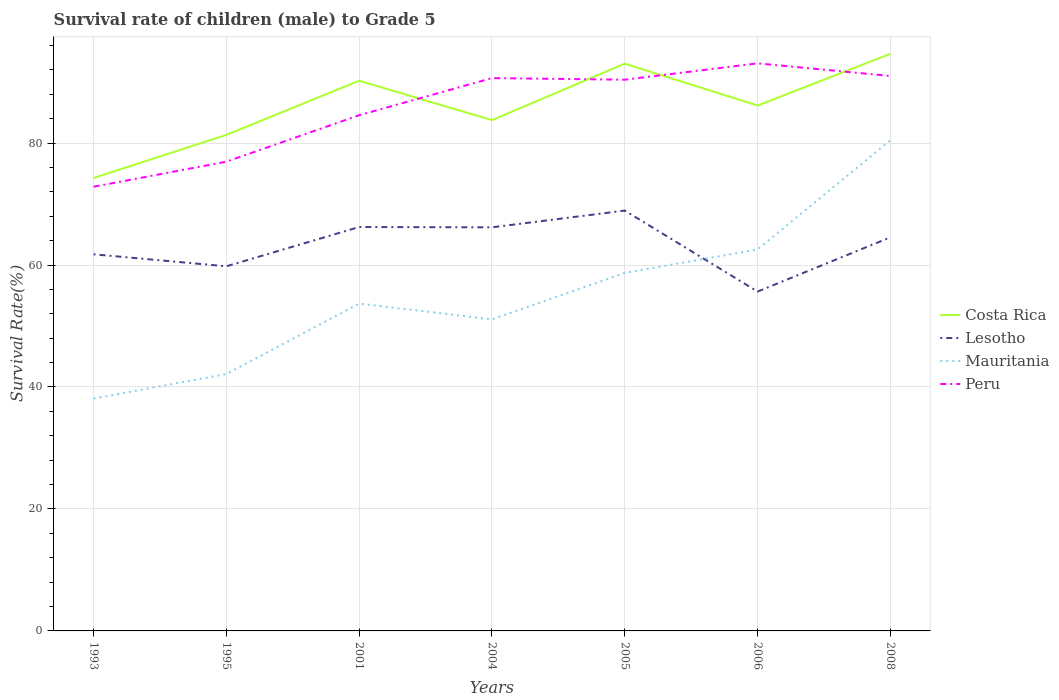Across all years, what is the maximum survival rate of male children to grade 5 in Lesotho?
Ensure brevity in your answer.  55.65. What is the total survival rate of male children to grade 5 in Mauritania in the graph?
Your answer should be compact. -15.57. What is the difference between the highest and the second highest survival rate of male children to grade 5 in Mauritania?
Offer a terse response. 42.36. How many lines are there?
Ensure brevity in your answer.  4. Does the graph contain grids?
Give a very brief answer. Yes. Where does the legend appear in the graph?
Ensure brevity in your answer.  Center right. What is the title of the graph?
Keep it short and to the point. Survival rate of children (male) to Grade 5. What is the label or title of the X-axis?
Your response must be concise. Years. What is the label or title of the Y-axis?
Provide a succinct answer. Survival Rate(%). What is the Survival Rate(%) of Costa Rica in 1993?
Ensure brevity in your answer.  74.27. What is the Survival Rate(%) of Lesotho in 1993?
Provide a succinct answer. 61.76. What is the Survival Rate(%) in Mauritania in 1993?
Give a very brief answer. 38.1. What is the Survival Rate(%) of Peru in 1993?
Your response must be concise. 72.83. What is the Survival Rate(%) of Costa Rica in 1995?
Ensure brevity in your answer.  81.34. What is the Survival Rate(%) of Lesotho in 1995?
Ensure brevity in your answer.  59.79. What is the Survival Rate(%) in Mauritania in 1995?
Provide a succinct answer. 42.12. What is the Survival Rate(%) in Peru in 1995?
Give a very brief answer. 76.94. What is the Survival Rate(%) of Costa Rica in 2001?
Provide a succinct answer. 90.22. What is the Survival Rate(%) of Lesotho in 2001?
Your answer should be very brief. 66.23. What is the Survival Rate(%) in Mauritania in 2001?
Give a very brief answer. 53.68. What is the Survival Rate(%) in Peru in 2001?
Offer a terse response. 84.56. What is the Survival Rate(%) in Costa Rica in 2004?
Your answer should be compact. 83.76. What is the Survival Rate(%) of Lesotho in 2004?
Offer a terse response. 66.18. What is the Survival Rate(%) of Mauritania in 2004?
Offer a terse response. 51.09. What is the Survival Rate(%) of Peru in 2004?
Your response must be concise. 90.65. What is the Survival Rate(%) of Costa Rica in 2005?
Provide a succinct answer. 93.02. What is the Survival Rate(%) in Lesotho in 2005?
Provide a succinct answer. 68.93. What is the Survival Rate(%) of Mauritania in 2005?
Your response must be concise. 58.7. What is the Survival Rate(%) in Peru in 2005?
Your answer should be compact. 90.39. What is the Survival Rate(%) in Costa Rica in 2006?
Ensure brevity in your answer.  86.16. What is the Survival Rate(%) in Lesotho in 2006?
Provide a succinct answer. 55.65. What is the Survival Rate(%) of Mauritania in 2006?
Keep it short and to the point. 62.55. What is the Survival Rate(%) in Peru in 2006?
Offer a terse response. 93.07. What is the Survival Rate(%) in Costa Rica in 2008?
Offer a terse response. 94.63. What is the Survival Rate(%) of Lesotho in 2008?
Provide a short and direct response. 64.55. What is the Survival Rate(%) in Mauritania in 2008?
Make the answer very short. 80.47. What is the Survival Rate(%) in Peru in 2008?
Your answer should be very brief. 91. Across all years, what is the maximum Survival Rate(%) in Costa Rica?
Offer a terse response. 94.63. Across all years, what is the maximum Survival Rate(%) of Lesotho?
Provide a short and direct response. 68.93. Across all years, what is the maximum Survival Rate(%) of Mauritania?
Your response must be concise. 80.47. Across all years, what is the maximum Survival Rate(%) in Peru?
Give a very brief answer. 93.07. Across all years, what is the minimum Survival Rate(%) of Costa Rica?
Your answer should be very brief. 74.27. Across all years, what is the minimum Survival Rate(%) of Lesotho?
Make the answer very short. 55.65. Across all years, what is the minimum Survival Rate(%) in Mauritania?
Keep it short and to the point. 38.1. Across all years, what is the minimum Survival Rate(%) of Peru?
Offer a terse response. 72.83. What is the total Survival Rate(%) in Costa Rica in the graph?
Your answer should be compact. 603.4. What is the total Survival Rate(%) in Lesotho in the graph?
Keep it short and to the point. 443.08. What is the total Survival Rate(%) of Mauritania in the graph?
Your answer should be very brief. 386.71. What is the total Survival Rate(%) of Peru in the graph?
Keep it short and to the point. 599.45. What is the difference between the Survival Rate(%) in Costa Rica in 1993 and that in 1995?
Give a very brief answer. -7.07. What is the difference between the Survival Rate(%) in Lesotho in 1993 and that in 1995?
Give a very brief answer. 1.97. What is the difference between the Survival Rate(%) of Mauritania in 1993 and that in 1995?
Offer a terse response. -4.02. What is the difference between the Survival Rate(%) in Peru in 1993 and that in 1995?
Provide a succinct answer. -4.11. What is the difference between the Survival Rate(%) of Costa Rica in 1993 and that in 2001?
Offer a very short reply. -15.95. What is the difference between the Survival Rate(%) of Lesotho in 1993 and that in 2001?
Your answer should be compact. -4.47. What is the difference between the Survival Rate(%) in Mauritania in 1993 and that in 2001?
Make the answer very short. -15.57. What is the difference between the Survival Rate(%) of Peru in 1993 and that in 2001?
Your answer should be compact. -11.73. What is the difference between the Survival Rate(%) in Costa Rica in 1993 and that in 2004?
Offer a very short reply. -9.49. What is the difference between the Survival Rate(%) of Lesotho in 1993 and that in 2004?
Keep it short and to the point. -4.42. What is the difference between the Survival Rate(%) in Mauritania in 1993 and that in 2004?
Your answer should be compact. -12.99. What is the difference between the Survival Rate(%) of Peru in 1993 and that in 2004?
Offer a very short reply. -17.82. What is the difference between the Survival Rate(%) of Costa Rica in 1993 and that in 2005?
Keep it short and to the point. -18.75. What is the difference between the Survival Rate(%) in Lesotho in 1993 and that in 2005?
Provide a succinct answer. -7.17. What is the difference between the Survival Rate(%) of Mauritania in 1993 and that in 2005?
Give a very brief answer. -20.6. What is the difference between the Survival Rate(%) of Peru in 1993 and that in 2005?
Your answer should be compact. -17.55. What is the difference between the Survival Rate(%) in Costa Rica in 1993 and that in 2006?
Provide a short and direct response. -11.89. What is the difference between the Survival Rate(%) of Lesotho in 1993 and that in 2006?
Your answer should be compact. 6.12. What is the difference between the Survival Rate(%) of Mauritania in 1993 and that in 2006?
Offer a very short reply. -24.45. What is the difference between the Survival Rate(%) in Peru in 1993 and that in 2006?
Ensure brevity in your answer.  -20.24. What is the difference between the Survival Rate(%) of Costa Rica in 1993 and that in 2008?
Ensure brevity in your answer.  -20.37. What is the difference between the Survival Rate(%) of Lesotho in 1993 and that in 2008?
Give a very brief answer. -2.79. What is the difference between the Survival Rate(%) in Mauritania in 1993 and that in 2008?
Make the answer very short. -42.36. What is the difference between the Survival Rate(%) in Peru in 1993 and that in 2008?
Your answer should be compact. -18.16. What is the difference between the Survival Rate(%) of Costa Rica in 1995 and that in 2001?
Provide a succinct answer. -8.88. What is the difference between the Survival Rate(%) of Lesotho in 1995 and that in 2001?
Offer a terse response. -6.44. What is the difference between the Survival Rate(%) of Mauritania in 1995 and that in 2001?
Your answer should be very brief. -11.55. What is the difference between the Survival Rate(%) of Peru in 1995 and that in 2001?
Provide a short and direct response. -7.62. What is the difference between the Survival Rate(%) in Costa Rica in 1995 and that in 2004?
Provide a succinct answer. -2.42. What is the difference between the Survival Rate(%) in Lesotho in 1995 and that in 2004?
Your answer should be very brief. -6.39. What is the difference between the Survival Rate(%) in Mauritania in 1995 and that in 2004?
Make the answer very short. -8.97. What is the difference between the Survival Rate(%) in Peru in 1995 and that in 2004?
Your answer should be compact. -13.71. What is the difference between the Survival Rate(%) in Costa Rica in 1995 and that in 2005?
Offer a terse response. -11.68. What is the difference between the Survival Rate(%) of Lesotho in 1995 and that in 2005?
Your response must be concise. -9.14. What is the difference between the Survival Rate(%) in Mauritania in 1995 and that in 2005?
Give a very brief answer. -16.58. What is the difference between the Survival Rate(%) in Peru in 1995 and that in 2005?
Provide a succinct answer. -13.44. What is the difference between the Survival Rate(%) in Costa Rica in 1995 and that in 2006?
Your response must be concise. -4.82. What is the difference between the Survival Rate(%) of Lesotho in 1995 and that in 2006?
Ensure brevity in your answer.  4.14. What is the difference between the Survival Rate(%) in Mauritania in 1995 and that in 2006?
Make the answer very short. -20.43. What is the difference between the Survival Rate(%) in Peru in 1995 and that in 2006?
Keep it short and to the point. -16.13. What is the difference between the Survival Rate(%) of Costa Rica in 1995 and that in 2008?
Your answer should be very brief. -13.29. What is the difference between the Survival Rate(%) in Lesotho in 1995 and that in 2008?
Provide a short and direct response. -4.76. What is the difference between the Survival Rate(%) of Mauritania in 1995 and that in 2008?
Your answer should be compact. -38.34. What is the difference between the Survival Rate(%) in Peru in 1995 and that in 2008?
Your answer should be very brief. -14.05. What is the difference between the Survival Rate(%) in Costa Rica in 2001 and that in 2004?
Provide a succinct answer. 6.46. What is the difference between the Survival Rate(%) in Lesotho in 2001 and that in 2004?
Give a very brief answer. 0.05. What is the difference between the Survival Rate(%) of Mauritania in 2001 and that in 2004?
Provide a short and direct response. 2.58. What is the difference between the Survival Rate(%) of Peru in 2001 and that in 2004?
Provide a short and direct response. -6.09. What is the difference between the Survival Rate(%) in Costa Rica in 2001 and that in 2005?
Your answer should be very brief. -2.8. What is the difference between the Survival Rate(%) of Lesotho in 2001 and that in 2005?
Your answer should be very brief. -2.69. What is the difference between the Survival Rate(%) in Mauritania in 2001 and that in 2005?
Your response must be concise. -5.03. What is the difference between the Survival Rate(%) in Peru in 2001 and that in 2005?
Ensure brevity in your answer.  -5.83. What is the difference between the Survival Rate(%) of Costa Rica in 2001 and that in 2006?
Your answer should be very brief. 4.06. What is the difference between the Survival Rate(%) in Lesotho in 2001 and that in 2006?
Your answer should be compact. 10.59. What is the difference between the Survival Rate(%) of Mauritania in 2001 and that in 2006?
Provide a short and direct response. -8.88. What is the difference between the Survival Rate(%) of Peru in 2001 and that in 2006?
Ensure brevity in your answer.  -8.51. What is the difference between the Survival Rate(%) of Costa Rica in 2001 and that in 2008?
Your response must be concise. -4.42. What is the difference between the Survival Rate(%) of Lesotho in 2001 and that in 2008?
Your response must be concise. 1.69. What is the difference between the Survival Rate(%) in Mauritania in 2001 and that in 2008?
Your response must be concise. -26.79. What is the difference between the Survival Rate(%) of Peru in 2001 and that in 2008?
Your response must be concise. -6.43. What is the difference between the Survival Rate(%) in Costa Rica in 2004 and that in 2005?
Keep it short and to the point. -9.26. What is the difference between the Survival Rate(%) in Lesotho in 2004 and that in 2005?
Your answer should be compact. -2.75. What is the difference between the Survival Rate(%) in Mauritania in 2004 and that in 2005?
Your answer should be compact. -7.61. What is the difference between the Survival Rate(%) in Peru in 2004 and that in 2005?
Provide a succinct answer. 0.26. What is the difference between the Survival Rate(%) in Costa Rica in 2004 and that in 2006?
Make the answer very short. -2.39. What is the difference between the Survival Rate(%) in Lesotho in 2004 and that in 2006?
Your answer should be very brief. 10.54. What is the difference between the Survival Rate(%) of Mauritania in 2004 and that in 2006?
Provide a succinct answer. -11.46. What is the difference between the Survival Rate(%) of Peru in 2004 and that in 2006?
Give a very brief answer. -2.42. What is the difference between the Survival Rate(%) in Costa Rica in 2004 and that in 2008?
Offer a very short reply. -10.87. What is the difference between the Survival Rate(%) in Lesotho in 2004 and that in 2008?
Offer a very short reply. 1.63. What is the difference between the Survival Rate(%) in Mauritania in 2004 and that in 2008?
Your response must be concise. -29.37. What is the difference between the Survival Rate(%) of Peru in 2004 and that in 2008?
Provide a short and direct response. -0.34. What is the difference between the Survival Rate(%) of Costa Rica in 2005 and that in 2006?
Give a very brief answer. 6.87. What is the difference between the Survival Rate(%) of Lesotho in 2005 and that in 2006?
Ensure brevity in your answer.  13.28. What is the difference between the Survival Rate(%) in Mauritania in 2005 and that in 2006?
Provide a succinct answer. -3.85. What is the difference between the Survival Rate(%) of Peru in 2005 and that in 2006?
Ensure brevity in your answer.  -2.68. What is the difference between the Survival Rate(%) in Costa Rica in 2005 and that in 2008?
Offer a very short reply. -1.61. What is the difference between the Survival Rate(%) of Lesotho in 2005 and that in 2008?
Offer a terse response. 4.38. What is the difference between the Survival Rate(%) in Mauritania in 2005 and that in 2008?
Provide a short and direct response. -21.76. What is the difference between the Survival Rate(%) of Peru in 2005 and that in 2008?
Provide a short and direct response. -0.61. What is the difference between the Survival Rate(%) in Costa Rica in 2006 and that in 2008?
Your response must be concise. -8.48. What is the difference between the Survival Rate(%) in Lesotho in 2006 and that in 2008?
Give a very brief answer. -8.9. What is the difference between the Survival Rate(%) in Mauritania in 2006 and that in 2008?
Ensure brevity in your answer.  -17.91. What is the difference between the Survival Rate(%) of Peru in 2006 and that in 2008?
Give a very brief answer. 2.07. What is the difference between the Survival Rate(%) of Costa Rica in 1993 and the Survival Rate(%) of Lesotho in 1995?
Your answer should be compact. 14.48. What is the difference between the Survival Rate(%) of Costa Rica in 1993 and the Survival Rate(%) of Mauritania in 1995?
Your answer should be very brief. 32.15. What is the difference between the Survival Rate(%) of Costa Rica in 1993 and the Survival Rate(%) of Peru in 1995?
Your response must be concise. -2.67. What is the difference between the Survival Rate(%) of Lesotho in 1993 and the Survival Rate(%) of Mauritania in 1995?
Provide a succinct answer. 19.64. What is the difference between the Survival Rate(%) of Lesotho in 1993 and the Survival Rate(%) of Peru in 1995?
Ensure brevity in your answer.  -15.18. What is the difference between the Survival Rate(%) in Mauritania in 1993 and the Survival Rate(%) in Peru in 1995?
Give a very brief answer. -38.84. What is the difference between the Survival Rate(%) of Costa Rica in 1993 and the Survival Rate(%) of Lesotho in 2001?
Ensure brevity in your answer.  8.04. What is the difference between the Survival Rate(%) in Costa Rica in 1993 and the Survival Rate(%) in Mauritania in 2001?
Your response must be concise. 20.59. What is the difference between the Survival Rate(%) in Costa Rica in 1993 and the Survival Rate(%) in Peru in 2001?
Offer a very short reply. -10.29. What is the difference between the Survival Rate(%) in Lesotho in 1993 and the Survival Rate(%) in Mauritania in 2001?
Provide a succinct answer. 8.09. What is the difference between the Survival Rate(%) in Lesotho in 1993 and the Survival Rate(%) in Peru in 2001?
Provide a short and direct response. -22.8. What is the difference between the Survival Rate(%) in Mauritania in 1993 and the Survival Rate(%) in Peru in 2001?
Your answer should be compact. -46.46. What is the difference between the Survival Rate(%) of Costa Rica in 1993 and the Survival Rate(%) of Lesotho in 2004?
Your response must be concise. 8.09. What is the difference between the Survival Rate(%) of Costa Rica in 1993 and the Survival Rate(%) of Mauritania in 2004?
Your answer should be very brief. 23.18. What is the difference between the Survival Rate(%) in Costa Rica in 1993 and the Survival Rate(%) in Peru in 2004?
Give a very brief answer. -16.38. What is the difference between the Survival Rate(%) in Lesotho in 1993 and the Survival Rate(%) in Mauritania in 2004?
Your response must be concise. 10.67. What is the difference between the Survival Rate(%) in Lesotho in 1993 and the Survival Rate(%) in Peru in 2004?
Make the answer very short. -28.89. What is the difference between the Survival Rate(%) in Mauritania in 1993 and the Survival Rate(%) in Peru in 2004?
Offer a terse response. -52.55. What is the difference between the Survival Rate(%) of Costa Rica in 1993 and the Survival Rate(%) of Lesotho in 2005?
Provide a succinct answer. 5.34. What is the difference between the Survival Rate(%) in Costa Rica in 1993 and the Survival Rate(%) in Mauritania in 2005?
Your answer should be very brief. 15.57. What is the difference between the Survival Rate(%) of Costa Rica in 1993 and the Survival Rate(%) of Peru in 2005?
Your response must be concise. -16.12. What is the difference between the Survival Rate(%) of Lesotho in 1993 and the Survival Rate(%) of Mauritania in 2005?
Make the answer very short. 3.06. What is the difference between the Survival Rate(%) of Lesotho in 1993 and the Survival Rate(%) of Peru in 2005?
Offer a very short reply. -28.63. What is the difference between the Survival Rate(%) in Mauritania in 1993 and the Survival Rate(%) in Peru in 2005?
Provide a succinct answer. -52.29. What is the difference between the Survival Rate(%) in Costa Rica in 1993 and the Survival Rate(%) in Lesotho in 2006?
Your response must be concise. 18.62. What is the difference between the Survival Rate(%) in Costa Rica in 1993 and the Survival Rate(%) in Mauritania in 2006?
Provide a succinct answer. 11.72. What is the difference between the Survival Rate(%) in Costa Rica in 1993 and the Survival Rate(%) in Peru in 2006?
Offer a very short reply. -18.8. What is the difference between the Survival Rate(%) of Lesotho in 1993 and the Survival Rate(%) of Mauritania in 2006?
Provide a succinct answer. -0.79. What is the difference between the Survival Rate(%) in Lesotho in 1993 and the Survival Rate(%) in Peru in 2006?
Make the answer very short. -31.31. What is the difference between the Survival Rate(%) of Mauritania in 1993 and the Survival Rate(%) of Peru in 2006?
Make the answer very short. -54.97. What is the difference between the Survival Rate(%) of Costa Rica in 1993 and the Survival Rate(%) of Lesotho in 2008?
Make the answer very short. 9.72. What is the difference between the Survival Rate(%) in Costa Rica in 1993 and the Survival Rate(%) in Mauritania in 2008?
Offer a terse response. -6.2. What is the difference between the Survival Rate(%) in Costa Rica in 1993 and the Survival Rate(%) in Peru in 2008?
Your answer should be very brief. -16.73. What is the difference between the Survival Rate(%) in Lesotho in 1993 and the Survival Rate(%) in Mauritania in 2008?
Make the answer very short. -18.71. What is the difference between the Survival Rate(%) of Lesotho in 1993 and the Survival Rate(%) of Peru in 2008?
Provide a short and direct response. -29.24. What is the difference between the Survival Rate(%) of Mauritania in 1993 and the Survival Rate(%) of Peru in 2008?
Provide a short and direct response. -52.9. What is the difference between the Survival Rate(%) in Costa Rica in 1995 and the Survival Rate(%) in Lesotho in 2001?
Keep it short and to the point. 15.11. What is the difference between the Survival Rate(%) of Costa Rica in 1995 and the Survival Rate(%) of Mauritania in 2001?
Keep it short and to the point. 27.67. What is the difference between the Survival Rate(%) in Costa Rica in 1995 and the Survival Rate(%) in Peru in 2001?
Offer a very short reply. -3.22. What is the difference between the Survival Rate(%) in Lesotho in 1995 and the Survival Rate(%) in Mauritania in 2001?
Your answer should be compact. 6.11. What is the difference between the Survival Rate(%) of Lesotho in 1995 and the Survival Rate(%) of Peru in 2001?
Provide a short and direct response. -24.77. What is the difference between the Survival Rate(%) in Mauritania in 1995 and the Survival Rate(%) in Peru in 2001?
Provide a succinct answer. -42.44. What is the difference between the Survival Rate(%) in Costa Rica in 1995 and the Survival Rate(%) in Lesotho in 2004?
Keep it short and to the point. 15.16. What is the difference between the Survival Rate(%) of Costa Rica in 1995 and the Survival Rate(%) of Mauritania in 2004?
Give a very brief answer. 30.25. What is the difference between the Survival Rate(%) in Costa Rica in 1995 and the Survival Rate(%) in Peru in 2004?
Provide a succinct answer. -9.31. What is the difference between the Survival Rate(%) in Lesotho in 1995 and the Survival Rate(%) in Mauritania in 2004?
Keep it short and to the point. 8.7. What is the difference between the Survival Rate(%) in Lesotho in 1995 and the Survival Rate(%) in Peru in 2004?
Offer a terse response. -30.86. What is the difference between the Survival Rate(%) of Mauritania in 1995 and the Survival Rate(%) of Peru in 2004?
Provide a short and direct response. -48.53. What is the difference between the Survival Rate(%) in Costa Rica in 1995 and the Survival Rate(%) in Lesotho in 2005?
Offer a terse response. 12.41. What is the difference between the Survival Rate(%) of Costa Rica in 1995 and the Survival Rate(%) of Mauritania in 2005?
Make the answer very short. 22.64. What is the difference between the Survival Rate(%) in Costa Rica in 1995 and the Survival Rate(%) in Peru in 2005?
Offer a terse response. -9.05. What is the difference between the Survival Rate(%) of Lesotho in 1995 and the Survival Rate(%) of Mauritania in 2005?
Give a very brief answer. 1.09. What is the difference between the Survival Rate(%) of Lesotho in 1995 and the Survival Rate(%) of Peru in 2005?
Your response must be concise. -30.6. What is the difference between the Survival Rate(%) in Mauritania in 1995 and the Survival Rate(%) in Peru in 2005?
Make the answer very short. -48.27. What is the difference between the Survival Rate(%) of Costa Rica in 1995 and the Survival Rate(%) of Lesotho in 2006?
Ensure brevity in your answer.  25.7. What is the difference between the Survival Rate(%) of Costa Rica in 1995 and the Survival Rate(%) of Mauritania in 2006?
Give a very brief answer. 18.79. What is the difference between the Survival Rate(%) in Costa Rica in 1995 and the Survival Rate(%) in Peru in 2006?
Keep it short and to the point. -11.73. What is the difference between the Survival Rate(%) of Lesotho in 1995 and the Survival Rate(%) of Mauritania in 2006?
Offer a terse response. -2.76. What is the difference between the Survival Rate(%) of Lesotho in 1995 and the Survival Rate(%) of Peru in 2006?
Your answer should be compact. -33.28. What is the difference between the Survival Rate(%) of Mauritania in 1995 and the Survival Rate(%) of Peru in 2006?
Give a very brief answer. -50.95. What is the difference between the Survival Rate(%) in Costa Rica in 1995 and the Survival Rate(%) in Lesotho in 2008?
Give a very brief answer. 16.79. What is the difference between the Survival Rate(%) in Costa Rica in 1995 and the Survival Rate(%) in Mauritania in 2008?
Offer a terse response. 0.87. What is the difference between the Survival Rate(%) in Costa Rica in 1995 and the Survival Rate(%) in Peru in 2008?
Your answer should be compact. -9.66. What is the difference between the Survival Rate(%) of Lesotho in 1995 and the Survival Rate(%) of Mauritania in 2008?
Provide a short and direct response. -20.68. What is the difference between the Survival Rate(%) in Lesotho in 1995 and the Survival Rate(%) in Peru in 2008?
Your answer should be compact. -31.21. What is the difference between the Survival Rate(%) in Mauritania in 1995 and the Survival Rate(%) in Peru in 2008?
Your response must be concise. -48.88. What is the difference between the Survival Rate(%) of Costa Rica in 2001 and the Survival Rate(%) of Lesotho in 2004?
Your answer should be very brief. 24.04. What is the difference between the Survival Rate(%) of Costa Rica in 2001 and the Survival Rate(%) of Mauritania in 2004?
Provide a short and direct response. 39.13. What is the difference between the Survival Rate(%) of Costa Rica in 2001 and the Survival Rate(%) of Peru in 2004?
Offer a very short reply. -0.43. What is the difference between the Survival Rate(%) of Lesotho in 2001 and the Survival Rate(%) of Mauritania in 2004?
Keep it short and to the point. 15.14. What is the difference between the Survival Rate(%) in Lesotho in 2001 and the Survival Rate(%) in Peru in 2004?
Keep it short and to the point. -24.42. What is the difference between the Survival Rate(%) of Mauritania in 2001 and the Survival Rate(%) of Peru in 2004?
Keep it short and to the point. -36.98. What is the difference between the Survival Rate(%) of Costa Rica in 2001 and the Survival Rate(%) of Lesotho in 2005?
Offer a very short reply. 21.29. What is the difference between the Survival Rate(%) of Costa Rica in 2001 and the Survival Rate(%) of Mauritania in 2005?
Provide a succinct answer. 31.52. What is the difference between the Survival Rate(%) of Costa Rica in 2001 and the Survival Rate(%) of Peru in 2005?
Your answer should be compact. -0.17. What is the difference between the Survival Rate(%) of Lesotho in 2001 and the Survival Rate(%) of Mauritania in 2005?
Your answer should be very brief. 7.53. What is the difference between the Survival Rate(%) in Lesotho in 2001 and the Survival Rate(%) in Peru in 2005?
Offer a very short reply. -24.16. What is the difference between the Survival Rate(%) in Mauritania in 2001 and the Survival Rate(%) in Peru in 2005?
Make the answer very short. -36.71. What is the difference between the Survival Rate(%) in Costa Rica in 2001 and the Survival Rate(%) in Lesotho in 2006?
Make the answer very short. 34.57. What is the difference between the Survival Rate(%) in Costa Rica in 2001 and the Survival Rate(%) in Mauritania in 2006?
Offer a terse response. 27.66. What is the difference between the Survival Rate(%) in Costa Rica in 2001 and the Survival Rate(%) in Peru in 2006?
Offer a terse response. -2.85. What is the difference between the Survival Rate(%) in Lesotho in 2001 and the Survival Rate(%) in Mauritania in 2006?
Make the answer very short. 3.68. What is the difference between the Survival Rate(%) in Lesotho in 2001 and the Survival Rate(%) in Peru in 2006?
Offer a terse response. -26.84. What is the difference between the Survival Rate(%) of Mauritania in 2001 and the Survival Rate(%) of Peru in 2006?
Give a very brief answer. -39.39. What is the difference between the Survival Rate(%) of Costa Rica in 2001 and the Survival Rate(%) of Lesotho in 2008?
Offer a very short reply. 25.67. What is the difference between the Survival Rate(%) of Costa Rica in 2001 and the Survival Rate(%) of Mauritania in 2008?
Provide a short and direct response. 9.75. What is the difference between the Survival Rate(%) in Costa Rica in 2001 and the Survival Rate(%) in Peru in 2008?
Make the answer very short. -0.78. What is the difference between the Survival Rate(%) in Lesotho in 2001 and the Survival Rate(%) in Mauritania in 2008?
Your answer should be compact. -14.23. What is the difference between the Survival Rate(%) of Lesotho in 2001 and the Survival Rate(%) of Peru in 2008?
Your answer should be compact. -24.77. What is the difference between the Survival Rate(%) of Mauritania in 2001 and the Survival Rate(%) of Peru in 2008?
Offer a terse response. -37.32. What is the difference between the Survival Rate(%) of Costa Rica in 2004 and the Survival Rate(%) of Lesotho in 2005?
Your answer should be compact. 14.83. What is the difference between the Survival Rate(%) in Costa Rica in 2004 and the Survival Rate(%) in Mauritania in 2005?
Give a very brief answer. 25.06. What is the difference between the Survival Rate(%) in Costa Rica in 2004 and the Survival Rate(%) in Peru in 2005?
Your answer should be compact. -6.63. What is the difference between the Survival Rate(%) in Lesotho in 2004 and the Survival Rate(%) in Mauritania in 2005?
Keep it short and to the point. 7.48. What is the difference between the Survival Rate(%) of Lesotho in 2004 and the Survival Rate(%) of Peru in 2005?
Your response must be concise. -24.21. What is the difference between the Survival Rate(%) of Mauritania in 2004 and the Survival Rate(%) of Peru in 2005?
Your answer should be very brief. -39.3. What is the difference between the Survival Rate(%) in Costa Rica in 2004 and the Survival Rate(%) in Lesotho in 2006?
Ensure brevity in your answer.  28.12. What is the difference between the Survival Rate(%) in Costa Rica in 2004 and the Survival Rate(%) in Mauritania in 2006?
Offer a very short reply. 21.21. What is the difference between the Survival Rate(%) of Costa Rica in 2004 and the Survival Rate(%) of Peru in 2006?
Ensure brevity in your answer.  -9.31. What is the difference between the Survival Rate(%) in Lesotho in 2004 and the Survival Rate(%) in Mauritania in 2006?
Your answer should be very brief. 3.63. What is the difference between the Survival Rate(%) of Lesotho in 2004 and the Survival Rate(%) of Peru in 2006?
Your answer should be compact. -26.89. What is the difference between the Survival Rate(%) in Mauritania in 2004 and the Survival Rate(%) in Peru in 2006?
Keep it short and to the point. -41.98. What is the difference between the Survival Rate(%) of Costa Rica in 2004 and the Survival Rate(%) of Lesotho in 2008?
Provide a succinct answer. 19.21. What is the difference between the Survival Rate(%) in Costa Rica in 2004 and the Survival Rate(%) in Mauritania in 2008?
Provide a short and direct response. 3.3. What is the difference between the Survival Rate(%) in Costa Rica in 2004 and the Survival Rate(%) in Peru in 2008?
Make the answer very short. -7.24. What is the difference between the Survival Rate(%) in Lesotho in 2004 and the Survival Rate(%) in Mauritania in 2008?
Your answer should be compact. -14.29. What is the difference between the Survival Rate(%) of Lesotho in 2004 and the Survival Rate(%) of Peru in 2008?
Offer a very short reply. -24.82. What is the difference between the Survival Rate(%) of Mauritania in 2004 and the Survival Rate(%) of Peru in 2008?
Offer a very short reply. -39.91. What is the difference between the Survival Rate(%) of Costa Rica in 2005 and the Survival Rate(%) of Lesotho in 2006?
Your answer should be very brief. 37.38. What is the difference between the Survival Rate(%) of Costa Rica in 2005 and the Survival Rate(%) of Mauritania in 2006?
Ensure brevity in your answer.  30.47. What is the difference between the Survival Rate(%) in Costa Rica in 2005 and the Survival Rate(%) in Peru in 2006?
Ensure brevity in your answer.  -0.05. What is the difference between the Survival Rate(%) of Lesotho in 2005 and the Survival Rate(%) of Mauritania in 2006?
Ensure brevity in your answer.  6.37. What is the difference between the Survival Rate(%) of Lesotho in 2005 and the Survival Rate(%) of Peru in 2006?
Keep it short and to the point. -24.14. What is the difference between the Survival Rate(%) of Mauritania in 2005 and the Survival Rate(%) of Peru in 2006?
Keep it short and to the point. -34.37. What is the difference between the Survival Rate(%) of Costa Rica in 2005 and the Survival Rate(%) of Lesotho in 2008?
Provide a succinct answer. 28.47. What is the difference between the Survival Rate(%) in Costa Rica in 2005 and the Survival Rate(%) in Mauritania in 2008?
Your answer should be compact. 12.56. What is the difference between the Survival Rate(%) in Costa Rica in 2005 and the Survival Rate(%) in Peru in 2008?
Keep it short and to the point. 2.02. What is the difference between the Survival Rate(%) of Lesotho in 2005 and the Survival Rate(%) of Mauritania in 2008?
Your response must be concise. -11.54. What is the difference between the Survival Rate(%) of Lesotho in 2005 and the Survival Rate(%) of Peru in 2008?
Your answer should be compact. -22.07. What is the difference between the Survival Rate(%) in Mauritania in 2005 and the Survival Rate(%) in Peru in 2008?
Ensure brevity in your answer.  -32.3. What is the difference between the Survival Rate(%) of Costa Rica in 2006 and the Survival Rate(%) of Lesotho in 2008?
Your answer should be very brief. 21.61. What is the difference between the Survival Rate(%) of Costa Rica in 2006 and the Survival Rate(%) of Mauritania in 2008?
Keep it short and to the point. 5.69. What is the difference between the Survival Rate(%) of Costa Rica in 2006 and the Survival Rate(%) of Peru in 2008?
Offer a very short reply. -4.84. What is the difference between the Survival Rate(%) of Lesotho in 2006 and the Survival Rate(%) of Mauritania in 2008?
Provide a succinct answer. -24.82. What is the difference between the Survival Rate(%) in Lesotho in 2006 and the Survival Rate(%) in Peru in 2008?
Your answer should be compact. -35.35. What is the difference between the Survival Rate(%) in Mauritania in 2006 and the Survival Rate(%) in Peru in 2008?
Your answer should be compact. -28.44. What is the average Survival Rate(%) in Costa Rica per year?
Give a very brief answer. 86.2. What is the average Survival Rate(%) in Lesotho per year?
Give a very brief answer. 63.3. What is the average Survival Rate(%) of Mauritania per year?
Keep it short and to the point. 55.24. What is the average Survival Rate(%) in Peru per year?
Offer a terse response. 85.64. In the year 1993, what is the difference between the Survival Rate(%) of Costa Rica and Survival Rate(%) of Lesotho?
Your answer should be compact. 12.51. In the year 1993, what is the difference between the Survival Rate(%) in Costa Rica and Survival Rate(%) in Mauritania?
Provide a succinct answer. 36.17. In the year 1993, what is the difference between the Survival Rate(%) of Costa Rica and Survival Rate(%) of Peru?
Your answer should be very brief. 1.44. In the year 1993, what is the difference between the Survival Rate(%) of Lesotho and Survival Rate(%) of Mauritania?
Give a very brief answer. 23.66. In the year 1993, what is the difference between the Survival Rate(%) in Lesotho and Survival Rate(%) in Peru?
Make the answer very short. -11.07. In the year 1993, what is the difference between the Survival Rate(%) of Mauritania and Survival Rate(%) of Peru?
Your response must be concise. -34.73. In the year 1995, what is the difference between the Survival Rate(%) of Costa Rica and Survival Rate(%) of Lesotho?
Your answer should be compact. 21.55. In the year 1995, what is the difference between the Survival Rate(%) of Costa Rica and Survival Rate(%) of Mauritania?
Offer a very short reply. 39.22. In the year 1995, what is the difference between the Survival Rate(%) of Costa Rica and Survival Rate(%) of Peru?
Provide a succinct answer. 4.4. In the year 1995, what is the difference between the Survival Rate(%) of Lesotho and Survival Rate(%) of Mauritania?
Your answer should be very brief. 17.67. In the year 1995, what is the difference between the Survival Rate(%) of Lesotho and Survival Rate(%) of Peru?
Your response must be concise. -17.15. In the year 1995, what is the difference between the Survival Rate(%) of Mauritania and Survival Rate(%) of Peru?
Your answer should be very brief. -34.82. In the year 2001, what is the difference between the Survival Rate(%) in Costa Rica and Survival Rate(%) in Lesotho?
Provide a succinct answer. 23.99. In the year 2001, what is the difference between the Survival Rate(%) of Costa Rica and Survival Rate(%) of Mauritania?
Ensure brevity in your answer.  36.54. In the year 2001, what is the difference between the Survival Rate(%) in Costa Rica and Survival Rate(%) in Peru?
Offer a very short reply. 5.66. In the year 2001, what is the difference between the Survival Rate(%) of Lesotho and Survival Rate(%) of Mauritania?
Offer a very short reply. 12.56. In the year 2001, what is the difference between the Survival Rate(%) of Lesotho and Survival Rate(%) of Peru?
Make the answer very short. -18.33. In the year 2001, what is the difference between the Survival Rate(%) in Mauritania and Survival Rate(%) in Peru?
Your answer should be compact. -30.89. In the year 2004, what is the difference between the Survival Rate(%) of Costa Rica and Survival Rate(%) of Lesotho?
Offer a terse response. 17.58. In the year 2004, what is the difference between the Survival Rate(%) in Costa Rica and Survival Rate(%) in Mauritania?
Your answer should be compact. 32.67. In the year 2004, what is the difference between the Survival Rate(%) of Costa Rica and Survival Rate(%) of Peru?
Ensure brevity in your answer.  -6.89. In the year 2004, what is the difference between the Survival Rate(%) in Lesotho and Survival Rate(%) in Mauritania?
Your answer should be compact. 15.09. In the year 2004, what is the difference between the Survival Rate(%) of Lesotho and Survival Rate(%) of Peru?
Provide a succinct answer. -24.47. In the year 2004, what is the difference between the Survival Rate(%) of Mauritania and Survival Rate(%) of Peru?
Offer a terse response. -39.56. In the year 2005, what is the difference between the Survival Rate(%) in Costa Rica and Survival Rate(%) in Lesotho?
Ensure brevity in your answer.  24.09. In the year 2005, what is the difference between the Survival Rate(%) in Costa Rica and Survival Rate(%) in Mauritania?
Your answer should be compact. 34.32. In the year 2005, what is the difference between the Survival Rate(%) of Costa Rica and Survival Rate(%) of Peru?
Ensure brevity in your answer.  2.63. In the year 2005, what is the difference between the Survival Rate(%) of Lesotho and Survival Rate(%) of Mauritania?
Make the answer very short. 10.22. In the year 2005, what is the difference between the Survival Rate(%) in Lesotho and Survival Rate(%) in Peru?
Your answer should be very brief. -21.46. In the year 2005, what is the difference between the Survival Rate(%) in Mauritania and Survival Rate(%) in Peru?
Offer a very short reply. -31.69. In the year 2006, what is the difference between the Survival Rate(%) in Costa Rica and Survival Rate(%) in Lesotho?
Provide a short and direct response. 30.51. In the year 2006, what is the difference between the Survival Rate(%) in Costa Rica and Survival Rate(%) in Mauritania?
Give a very brief answer. 23.6. In the year 2006, what is the difference between the Survival Rate(%) of Costa Rica and Survival Rate(%) of Peru?
Keep it short and to the point. -6.91. In the year 2006, what is the difference between the Survival Rate(%) of Lesotho and Survival Rate(%) of Mauritania?
Make the answer very short. -6.91. In the year 2006, what is the difference between the Survival Rate(%) in Lesotho and Survival Rate(%) in Peru?
Keep it short and to the point. -37.42. In the year 2006, what is the difference between the Survival Rate(%) of Mauritania and Survival Rate(%) of Peru?
Offer a terse response. -30.52. In the year 2008, what is the difference between the Survival Rate(%) in Costa Rica and Survival Rate(%) in Lesotho?
Your response must be concise. 30.09. In the year 2008, what is the difference between the Survival Rate(%) of Costa Rica and Survival Rate(%) of Mauritania?
Your answer should be compact. 14.17. In the year 2008, what is the difference between the Survival Rate(%) of Costa Rica and Survival Rate(%) of Peru?
Your response must be concise. 3.64. In the year 2008, what is the difference between the Survival Rate(%) of Lesotho and Survival Rate(%) of Mauritania?
Keep it short and to the point. -15.92. In the year 2008, what is the difference between the Survival Rate(%) in Lesotho and Survival Rate(%) in Peru?
Offer a very short reply. -26.45. In the year 2008, what is the difference between the Survival Rate(%) in Mauritania and Survival Rate(%) in Peru?
Provide a succinct answer. -10.53. What is the ratio of the Survival Rate(%) of Costa Rica in 1993 to that in 1995?
Offer a terse response. 0.91. What is the ratio of the Survival Rate(%) of Lesotho in 1993 to that in 1995?
Offer a very short reply. 1.03. What is the ratio of the Survival Rate(%) in Mauritania in 1993 to that in 1995?
Make the answer very short. 0.9. What is the ratio of the Survival Rate(%) of Peru in 1993 to that in 1995?
Ensure brevity in your answer.  0.95. What is the ratio of the Survival Rate(%) in Costa Rica in 1993 to that in 2001?
Offer a very short reply. 0.82. What is the ratio of the Survival Rate(%) in Lesotho in 1993 to that in 2001?
Offer a terse response. 0.93. What is the ratio of the Survival Rate(%) of Mauritania in 1993 to that in 2001?
Give a very brief answer. 0.71. What is the ratio of the Survival Rate(%) in Peru in 1993 to that in 2001?
Make the answer very short. 0.86. What is the ratio of the Survival Rate(%) of Costa Rica in 1993 to that in 2004?
Give a very brief answer. 0.89. What is the ratio of the Survival Rate(%) of Lesotho in 1993 to that in 2004?
Your answer should be very brief. 0.93. What is the ratio of the Survival Rate(%) of Mauritania in 1993 to that in 2004?
Offer a terse response. 0.75. What is the ratio of the Survival Rate(%) in Peru in 1993 to that in 2004?
Offer a terse response. 0.8. What is the ratio of the Survival Rate(%) of Costa Rica in 1993 to that in 2005?
Give a very brief answer. 0.8. What is the ratio of the Survival Rate(%) in Lesotho in 1993 to that in 2005?
Keep it short and to the point. 0.9. What is the ratio of the Survival Rate(%) in Mauritania in 1993 to that in 2005?
Give a very brief answer. 0.65. What is the ratio of the Survival Rate(%) of Peru in 1993 to that in 2005?
Your response must be concise. 0.81. What is the ratio of the Survival Rate(%) in Costa Rica in 1993 to that in 2006?
Offer a terse response. 0.86. What is the ratio of the Survival Rate(%) in Lesotho in 1993 to that in 2006?
Your answer should be very brief. 1.11. What is the ratio of the Survival Rate(%) of Mauritania in 1993 to that in 2006?
Your answer should be compact. 0.61. What is the ratio of the Survival Rate(%) in Peru in 1993 to that in 2006?
Offer a very short reply. 0.78. What is the ratio of the Survival Rate(%) of Costa Rica in 1993 to that in 2008?
Offer a terse response. 0.78. What is the ratio of the Survival Rate(%) in Lesotho in 1993 to that in 2008?
Offer a very short reply. 0.96. What is the ratio of the Survival Rate(%) of Mauritania in 1993 to that in 2008?
Keep it short and to the point. 0.47. What is the ratio of the Survival Rate(%) of Peru in 1993 to that in 2008?
Give a very brief answer. 0.8. What is the ratio of the Survival Rate(%) in Costa Rica in 1995 to that in 2001?
Make the answer very short. 0.9. What is the ratio of the Survival Rate(%) in Lesotho in 1995 to that in 2001?
Give a very brief answer. 0.9. What is the ratio of the Survival Rate(%) of Mauritania in 1995 to that in 2001?
Ensure brevity in your answer.  0.78. What is the ratio of the Survival Rate(%) of Peru in 1995 to that in 2001?
Your answer should be very brief. 0.91. What is the ratio of the Survival Rate(%) in Costa Rica in 1995 to that in 2004?
Provide a succinct answer. 0.97. What is the ratio of the Survival Rate(%) of Lesotho in 1995 to that in 2004?
Keep it short and to the point. 0.9. What is the ratio of the Survival Rate(%) in Mauritania in 1995 to that in 2004?
Provide a succinct answer. 0.82. What is the ratio of the Survival Rate(%) of Peru in 1995 to that in 2004?
Make the answer very short. 0.85. What is the ratio of the Survival Rate(%) in Costa Rica in 1995 to that in 2005?
Ensure brevity in your answer.  0.87. What is the ratio of the Survival Rate(%) in Lesotho in 1995 to that in 2005?
Offer a very short reply. 0.87. What is the ratio of the Survival Rate(%) in Mauritania in 1995 to that in 2005?
Ensure brevity in your answer.  0.72. What is the ratio of the Survival Rate(%) of Peru in 1995 to that in 2005?
Provide a succinct answer. 0.85. What is the ratio of the Survival Rate(%) in Costa Rica in 1995 to that in 2006?
Your answer should be compact. 0.94. What is the ratio of the Survival Rate(%) in Lesotho in 1995 to that in 2006?
Make the answer very short. 1.07. What is the ratio of the Survival Rate(%) of Mauritania in 1995 to that in 2006?
Provide a succinct answer. 0.67. What is the ratio of the Survival Rate(%) of Peru in 1995 to that in 2006?
Ensure brevity in your answer.  0.83. What is the ratio of the Survival Rate(%) in Costa Rica in 1995 to that in 2008?
Offer a very short reply. 0.86. What is the ratio of the Survival Rate(%) in Lesotho in 1995 to that in 2008?
Give a very brief answer. 0.93. What is the ratio of the Survival Rate(%) of Mauritania in 1995 to that in 2008?
Offer a very short reply. 0.52. What is the ratio of the Survival Rate(%) of Peru in 1995 to that in 2008?
Give a very brief answer. 0.85. What is the ratio of the Survival Rate(%) of Costa Rica in 2001 to that in 2004?
Keep it short and to the point. 1.08. What is the ratio of the Survival Rate(%) in Mauritania in 2001 to that in 2004?
Offer a very short reply. 1.05. What is the ratio of the Survival Rate(%) in Peru in 2001 to that in 2004?
Your answer should be very brief. 0.93. What is the ratio of the Survival Rate(%) in Costa Rica in 2001 to that in 2005?
Provide a succinct answer. 0.97. What is the ratio of the Survival Rate(%) of Lesotho in 2001 to that in 2005?
Your answer should be very brief. 0.96. What is the ratio of the Survival Rate(%) in Mauritania in 2001 to that in 2005?
Give a very brief answer. 0.91. What is the ratio of the Survival Rate(%) in Peru in 2001 to that in 2005?
Your answer should be compact. 0.94. What is the ratio of the Survival Rate(%) in Costa Rica in 2001 to that in 2006?
Make the answer very short. 1.05. What is the ratio of the Survival Rate(%) in Lesotho in 2001 to that in 2006?
Keep it short and to the point. 1.19. What is the ratio of the Survival Rate(%) of Mauritania in 2001 to that in 2006?
Make the answer very short. 0.86. What is the ratio of the Survival Rate(%) of Peru in 2001 to that in 2006?
Offer a very short reply. 0.91. What is the ratio of the Survival Rate(%) of Costa Rica in 2001 to that in 2008?
Make the answer very short. 0.95. What is the ratio of the Survival Rate(%) in Lesotho in 2001 to that in 2008?
Provide a succinct answer. 1.03. What is the ratio of the Survival Rate(%) in Mauritania in 2001 to that in 2008?
Offer a very short reply. 0.67. What is the ratio of the Survival Rate(%) of Peru in 2001 to that in 2008?
Your answer should be very brief. 0.93. What is the ratio of the Survival Rate(%) in Costa Rica in 2004 to that in 2005?
Offer a very short reply. 0.9. What is the ratio of the Survival Rate(%) of Lesotho in 2004 to that in 2005?
Give a very brief answer. 0.96. What is the ratio of the Survival Rate(%) of Mauritania in 2004 to that in 2005?
Offer a terse response. 0.87. What is the ratio of the Survival Rate(%) in Costa Rica in 2004 to that in 2006?
Offer a terse response. 0.97. What is the ratio of the Survival Rate(%) in Lesotho in 2004 to that in 2006?
Your answer should be very brief. 1.19. What is the ratio of the Survival Rate(%) in Mauritania in 2004 to that in 2006?
Ensure brevity in your answer.  0.82. What is the ratio of the Survival Rate(%) in Peru in 2004 to that in 2006?
Your response must be concise. 0.97. What is the ratio of the Survival Rate(%) in Costa Rica in 2004 to that in 2008?
Give a very brief answer. 0.89. What is the ratio of the Survival Rate(%) of Lesotho in 2004 to that in 2008?
Keep it short and to the point. 1.03. What is the ratio of the Survival Rate(%) in Mauritania in 2004 to that in 2008?
Your response must be concise. 0.64. What is the ratio of the Survival Rate(%) of Costa Rica in 2005 to that in 2006?
Your response must be concise. 1.08. What is the ratio of the Survival Rate(%) of Lesotho in 2005 to that in 2006?
Your response must be concise. 1.24. What is the ratio of the Survival Rate(%) in Mauritania in 2005 to that in 2006?
Your response must be concise. 0.94. What is the ratio of the Survival Rate(%) in Peru in 2005 to that in 2006?
Provide a short and direct response. 0.97. What is the ratio of the Survival Rate(%) of Lesotho in 2005 to that in 2008?
Provide a short and direct response. 1.07. What is the ratio of the Survival Rate(%) in Mauritania in 2005 to that in 2008?
Provide a succinct answer. 0.73. What is the ratio of the Survival Rate(%) of Costa Rica in 2006 to that in 2008?
Provide a short and direct response. 0.91. What is the ratio of the Survival Rate(%) of Lesotho in 2006 to that in 2008?
Keep it short and to the point. 0.86. What is the ratio of the Survival Rate(%) in Mauritania in 2006 to that in 2008?
Ensure brevity in your answer.  0.78. What is the ratio of the Survival Rate(%) of Peru in 2006 to that in 2008?
Your answer should be compact. 1.02. What is the difference between the highest and the second highest Survival Rate(%) in Costa Rica?
Your answer should be very brief. 1.61. What is the difference between the highest and the second highest Survival Rate(%) in Lesotho?
Offer a terse response. 2.69. What is the difference between the highest and the second highest Survival Rate(%) of Mauritania?
Your response must be concise. 17.91. What is the difference between the highest and the second highest Survival Rate(%) of Peru?
Your response must be concise. 2.07. What is the difference between the highest and the lowest Survival Rate(%) in Costa Rica?
Your answer should be compact. 20.37. What is the difference between the highest and the lowest Survival Rate(%) in Lesotho?
Your answer should be very brief. 13.28. What is the difference between the highest and the lowest Survival Rate(%) in Mauritania?
Give a very brief answer. 42.36. What is the difference between the highest and the lowest Survival Rate(%) of Peru?
Ensure brevity in your answer.  20.24. 